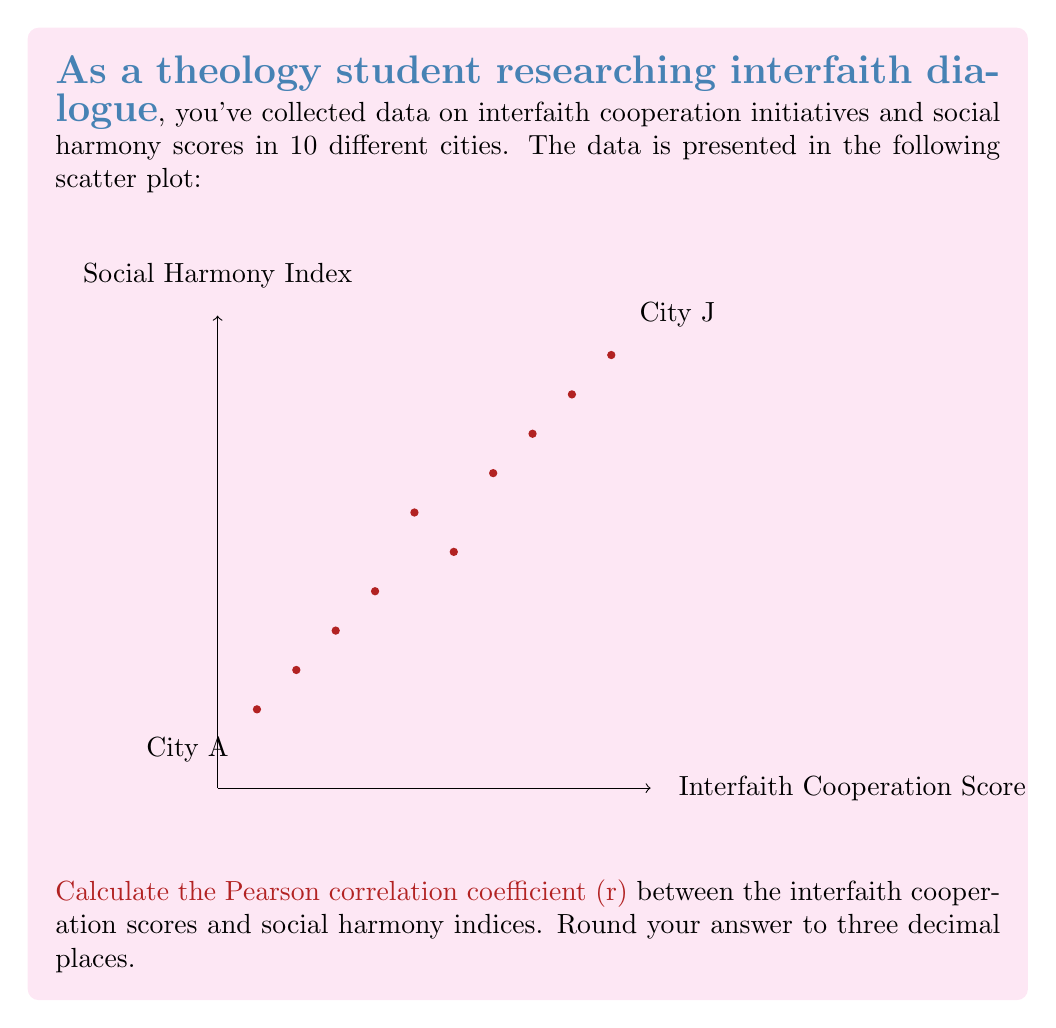Help me with this question. To calculate the Pearson correlation coefficient (r), we'll use the formula:

$$ r = \frac{\sum_{i=1}^{n} (x_i - \bar{x})(y_i - \bar{y})}{\sqrt{\sum_{i=1}^{n} (x_i - \bar{x})^2 \sum_{i=1}^{n} (y_i - \bar{y})^2}} $$

Where:
$x_i$ = interfaith cooperation scores
$y_i$ = social harmony indices
$\bar{x}$ = mean of x values
$\bar{y}$ = mean of y values
n = number of data points (10 in this case)

Step 1: Calculate means
$\bar{x} = \frac{1+2+3+4+5+6+7+8+9+10}{10} = 5.5$
$\bar{y} = \frac{2+3+4+5+7+6+8+9+10+11}{10} = 6.5$

Step 2: Calculate $(x_i - \bar{x})$, $(y_i - \bar{y})$, $(x_i - \bar{x})^2$, $(y_i - \bar{y})^2$, and $(x_i - \bar{x})(y_i - \bar{y})$ for each data point.

Step 3: Sum up the values calculated in step 2:
$\sum (x_i - \bar{x})(y_i - \bar{y}) = 82.5$
$\sum (x_i - \bar{x})^2 = 82.5$
$\sum (y_i - \bar{y})^2 = 90.5$

Step 4: Apply the formula:

$$ r = \frac{82.5}{\sqrt{82.5 \times 90.5}} = \frac{82.5}{86.52} \approx 0.954 $$

Step 5: Round to three decimal places: 0.954
Answer: 0.954 